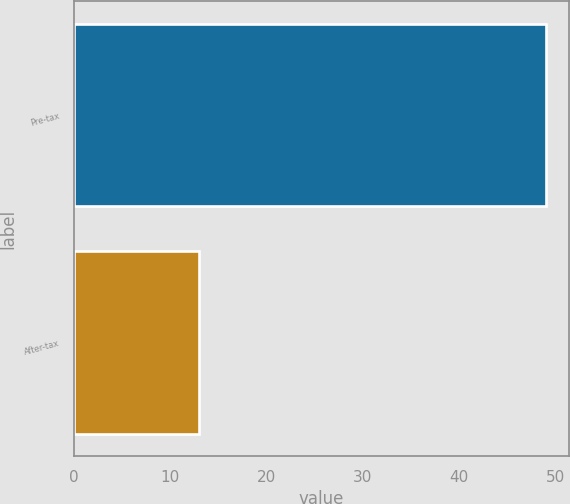<chart> <loc_0><loc_0><loc_500><loc_500><bar_chart><fcel>Pre-tax<fcel>After-tax<nl><fcel>49<fcel>13<nl></chart> 